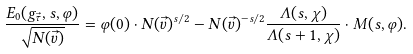<formula> <loc_0><loc_0><loc_500><loc_500>\frac { E _ { 0 } ( g _ { \vec { \tau } } , s , \varphi ) } { \sqrt { N ( \vec { v } ) } } = \varphi ( 0 ) \cdot N ( \vec { v } ) ^ { s / 2 } - N ( \vec { v } ) ^ { - s / 2 } \frac { \Lambda ( s , \chi ) } { \Lambda ( s + 1 , \chi ) } \cdot M ( s , \varphi ) .</formula> 